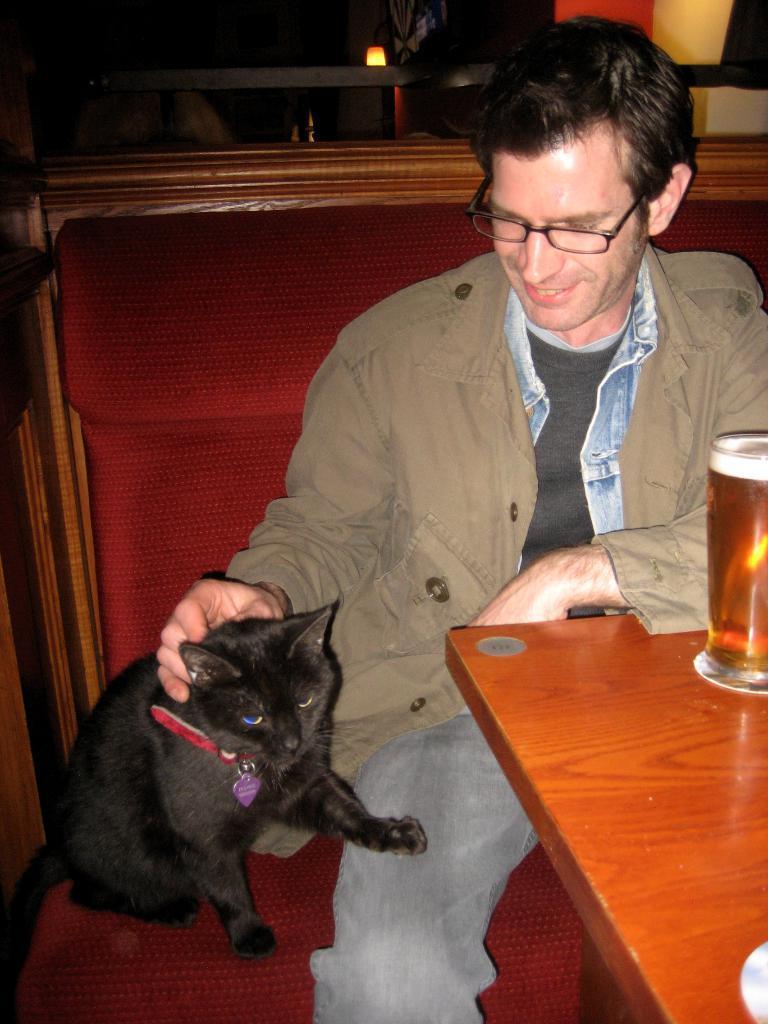Can you describe this image briefly? In this image I can see a person smiling and sitting on the chair and that person is holding the cat. In front of that person there is a table. On the table there is glass. 